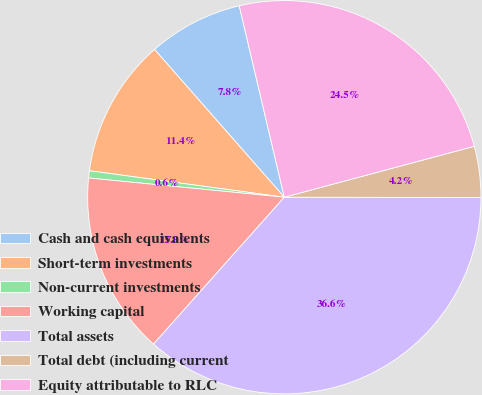Convert chart. <chart><loc_0><loc_0><loc_500><loc_500><pie_chart><fcel>Cash and cash equivalents<fcel>Short-term investments<fcel>Non-current investments<fcel>Working capital<fcel>Total assets<fcel>Total debt (including current<fcel>Equity attributable to RLC<nl><fcel>7.79%<fcel>11.38%<fcel>0.59%<fcel>14.98%<fcel>36.56%<fcel>4.19%<fcel>24.51%<nl></chart> 